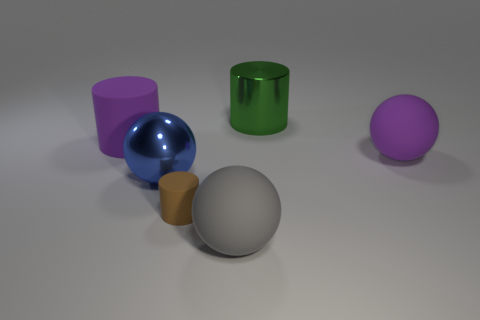Are the large green cylinder and the blue thing behind the brown cylinder made of the same material?
Ensure brevity in your answer.  Yes. What is the color of the metallic object that is in front of the matte cylinder that is behind the matte cylinder that is in front of the big blue metal sphere?
Your answer should be compact. Blue. There is a gray ball that is the same size as the green cylinder; what is it made of?
Your response must be concise. Rubber. What number of large gray spheres are made of the same material as the green cylinder?
Make the answer very short. 0. There is a purple object on the right side of the tiny brown matte thing; does it have the same size as the rubber ball that is to the left of the purple matte ball?
Ensure brevity in your answer.  Yes. There is a large ball right of the large gray ball; what is its color?
Ensure brevity in your answer.  Purple. How many other big shiny cylinders are the same color as the metallic cylinder?
Your answer should be compact. 0. Do the green metallic cylinder and the shiny thing to the left of the metallic cylinder have the same size?
Offer a terse response. Yes. What is the size of the matte object right of the metal thing behind the big matte ball behind the small brown cylinder?
Make the answer very short. Large. There is a big matte cylinder; what number of large metallic things are in front of it?
Offer a very short reply. 1. 